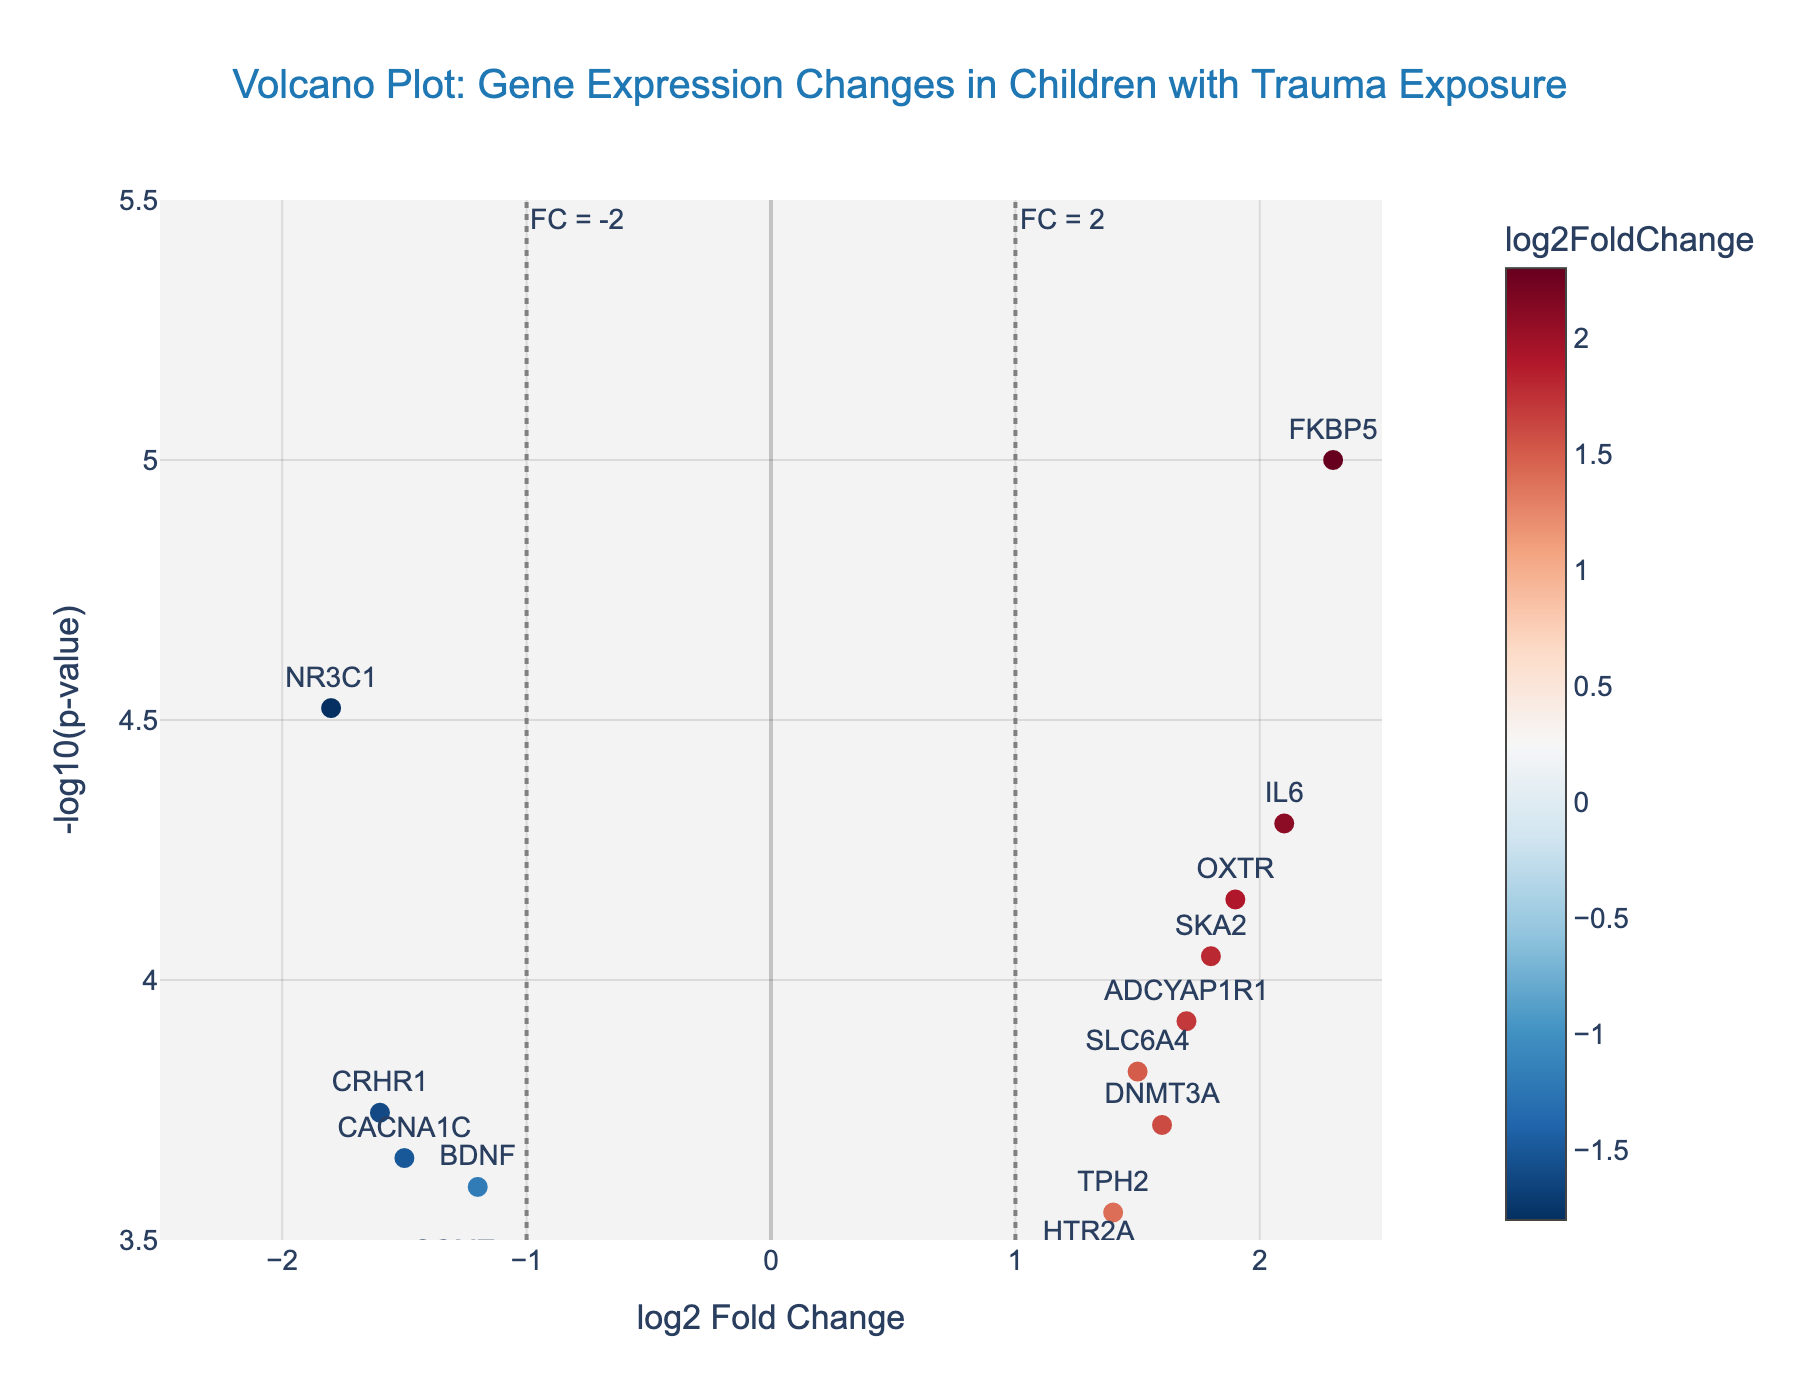what's the title of the figure? The title is displayed at the top center of the plot. It reads "Volcano Plot: Gene Expression Changes in Children with Trauma Exposure."
Answer: Volcano Plot: Gene Expression Changes in Children with Trauma Exposure how many genes show a positive log2 fold change? To determine the number of genes with a positive log2 fold change, count the points to the right of the y-axis (log2 fold change > 0).
Answer: 8 which gene has the highest -log10(p-value)? The highest y-value on the plot corresponds to the highest -log10(p-value). Look for the gene at the topmost point.
Answer: FKBP5 which genes have a log2 fold change between -1.5 and 1.5? Identify the genes within the range of -1.5 to 1.5 on the x-axis. Look for points between these limits and note their labels.
Answer: NR3C1, BDNF, CRHR1, HTR2A, TPH2, MAOA, COMT, CACNA1C, DNMT3A what is the significance threshold used in the plot? The plot contains a horizontal line marked “p = 0.001.” This line indicates the significance threshold used.
Answer: p = 0.001 which gene has the most substantial negative log2 fold change? To find the gene with the most substantial negative log2 fold change, locate the point furthest to the left on the x-axis.
Answer: NR3C1 how many genes have a -log10(p-value) greater than 4? Count the number of points above the y-value of 4. These points reflect genes with a -log10(p-value) > 4.
Answer: 6 what is the log2 fold change value for the gene IL6? Find the point labeled "IL6" in the plot and read its x-axis value.
Answer: 2.1 which two genes have the closest log2 fold change values? Examine the x-axis values and identify two genes whose points are closest to each other horizontally.
Answer: FKBP5 and OXTR which genes are marked as having a significant fold change using the vertical threshold lines? Identify the genes outside the vertical lines marked "FC = -2" and "FC = 2" on the x-axis. These lines indicate significant fold changes.
Answer: No genes where do most genes fall in the plot? Observe the overall distribution of points to see where the majority are concentrated horizontally and vertically.
Answer: Near the center with moderate -log10(p-values) among SLC6A4, SKA2, and DNMT3A, which gene has the lowest -log10(p-value)? Compare the y-axis values for SLC6A4, SKA2, and DNMT3A, and identify the one with the lowest y-value.
Answer: DNMT3A 